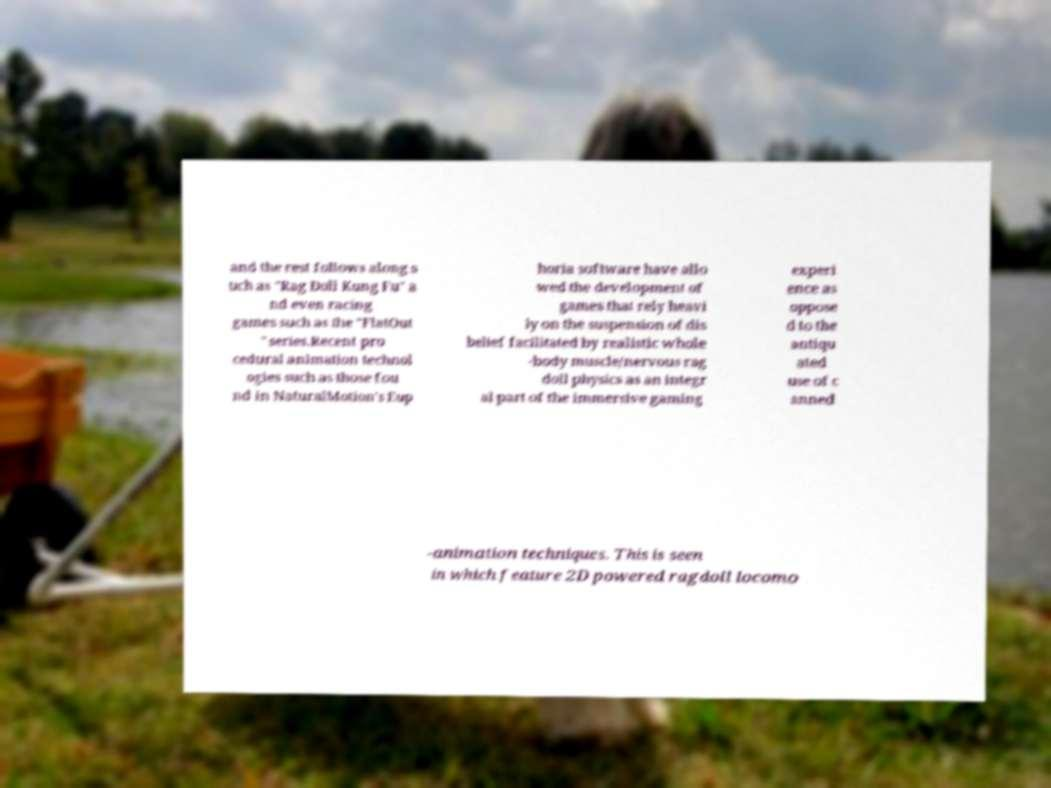For documentation purposes, I need the text within this image transcribed. Could you provide that? and the rest follows along s uch as "Rag Doll Kung Fu" a nd even racing games such as the "FlatOut " series.Recent pro cedural animation technol ogies such as those fou nd in NaturalMotion's Eup horia software have allo wed the development of games that rely heavi ly on the suspension of dis belief facilitated by realistic whole -body muscle/nervous rag doll physics as an integr al part of the immersive gaming experi ence as oppose d to the antiqu ated use of c anned -animation techniques. This is seen in which feature 2D powered ragdoll locomo 